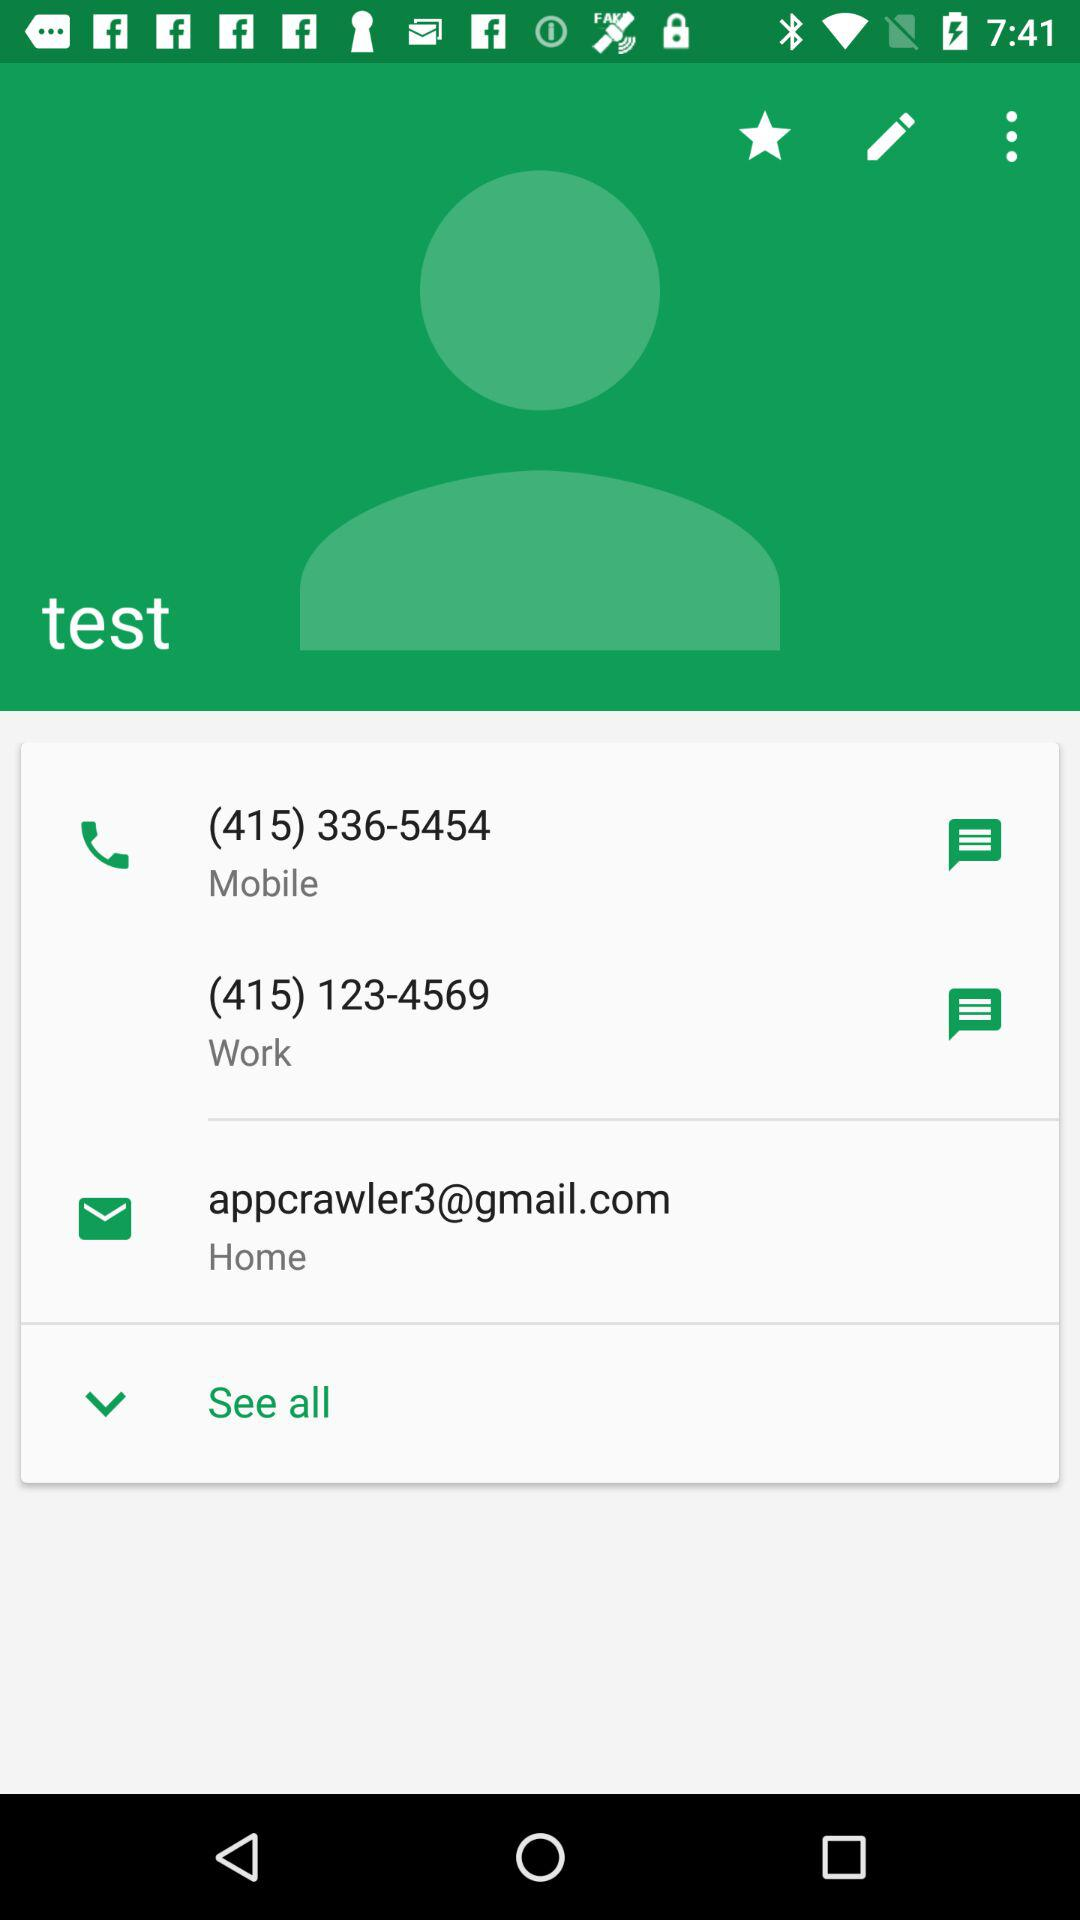What is the email address? The email address is appcrawler3@gmail.com. 